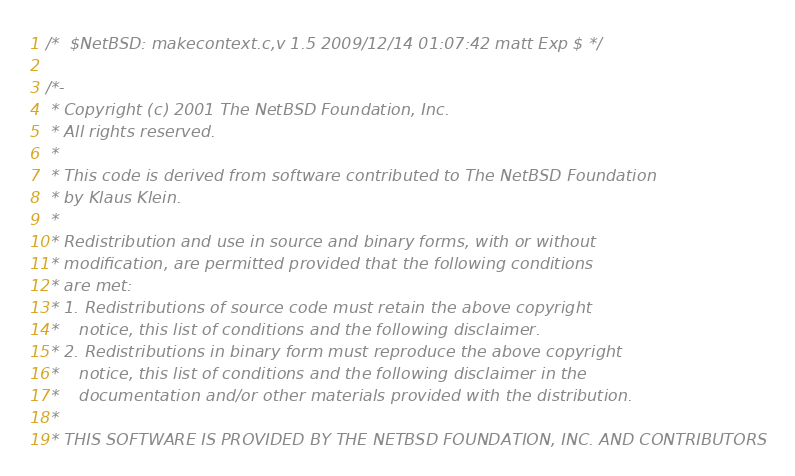Convert code to text. <code><loc_0><loc_0><loc_500><loc_500><_C_>/*	$NetBSD: makecontext.c,v 1.5 2009/12/14 01:07:42 matt Exp $	*/

/*-
 * Copyright (c) 2001 The NetBSD Foundation, Inc.
 * All rights reserved.
 *
 * This code is derived from software contributed to The NetBSD Foundation
 * by Klaus Klein.
 *
 * Redistribution and use in source and binary forms, with or without
 * modification, are permitted provided that the following conditions
 * are met:
 * 1. Redistributions of source code must retain the above copyright
 *    notice, this list of conditions and the following disclaimer.
 * 2. Redistributions in binary form must reproduce the above copyright
 *    notice, this list of conditions and the following disclaimer in the
 *    documentation and/or other materials provided with the distribution.
 *
 * THIS SOFTWARE IS PROVIDED BY THE NETBSD FOUNDATION, INC. AND CONTRIBUTORS</code> 